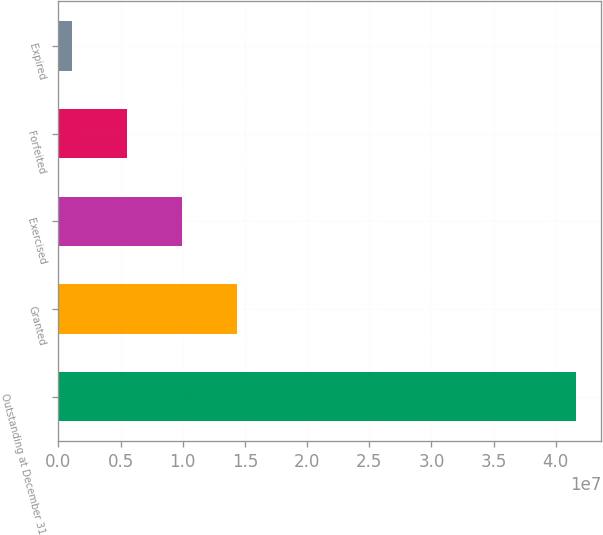Convert chart. <chart><loc_0><loc_0><loc_500><loc_500><bar_chart><fcel>Outstanding at December 31<fcel>Granted<fcel>Exercised<fcel>Forfeited<fcel>Expired<nl><fcel>4.15913e+07<fcel>1.43741e+07<fcel>9.93683e+06<fcel>5.49957e+06<fcel>1.06231e+06<nl></chart> 